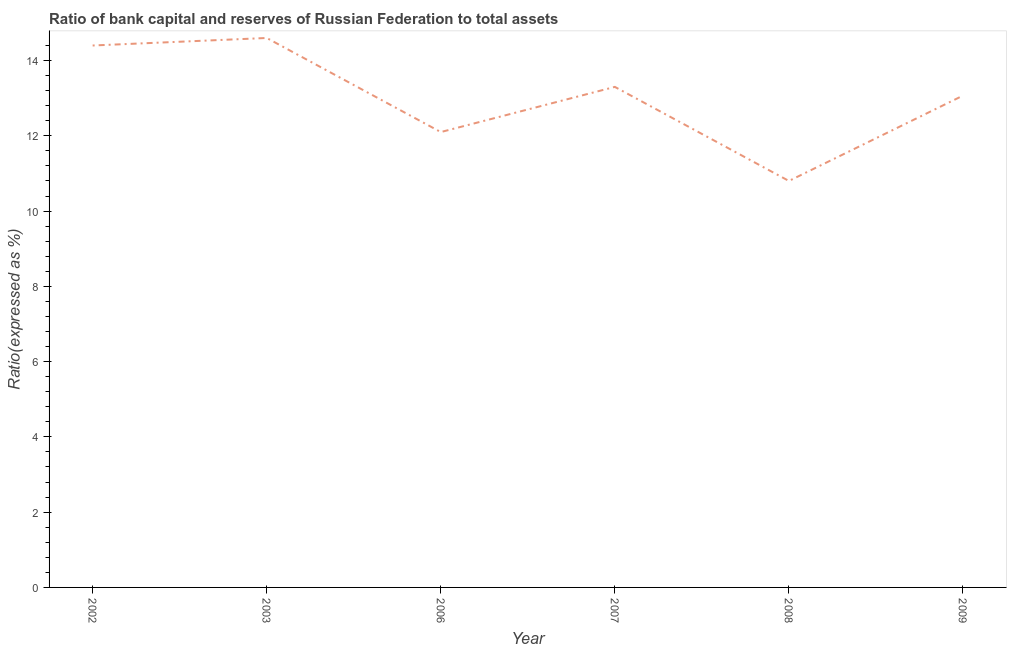Across all years, what is the minimum bank capital to assets ratio?
Make the answer very short. 10.8. In which year was the bank capital to assets ratio minimum?
Your answer should be very brief. 2008. What is the sum of the bank capital to assets ratio?
Your answer should be compact. 78.27. What is the difference between the bank capital to assets ratio in 2002 and 2009?
Give a very brief answer. 1.33. What is the average bank capital to assets ratio per year?
Provide a succinct answer. 13.04. What is the median bank capital to assets ratio?
Make the answer very short. 13.18. In how many years, is the bank capital to assets ratio greater than 9.2 %?
Offer a terse response. 6. Do a majority of the years between 2006 and 2003 (inclusive) have bank capital to assets ratio greater than 9.6 %?
Give a very brief answer. No. What is the ratio of the bank capital to assets ratio in 2002 to that in 2006?
Ensure brevity in your answer.  1.19. What is the difference between the highest and the second highest bank capital to assets ratio?
Give a very brief answer. 0.2. What is the difference between the highest and the lowest bank capital to assets ratio?
Provide a short and direct response. 3.8. Does the bank capital to assets ratio monotonically increase over the years?
Ensure brevity in your answer.  No. How many lines are there?
Your answer should be compact. 1. What is the difference between two consecutive major ticks on the Y-axis?
Keep it short and to the point. 2. Are the values on the major ticks of Y-axis written in scientific E-notation?
Ensure brevity in your answer.  No. What is the title of the graph?
Your answer should be compact. Ratio of bank capital and reserves of Russian Federation to total assets. What is the label or title of the X-axis?
Make the answer very short. Year. What is the label or title of the Y-axis?
Give a very brief answer. Ratio(expressed as %). What is the Ratio(expressed as %) in 2002?
Your response must be concise. 14.4. What is the Ratio(expressed as %) of 2003?
Your answer should be compact. 14.6. What is the Ratio(expressed as %) in 2006?
Give a very brief answer. 12.1. What is the Ratio(expressed as %) of 2008?
Ensure brevity in your answer.  10.8. What is the Ratio(expressed as %) in 2009?
Make the answer very short. 13.07. What is the difference between the Ratio(expressed as %) in 2002 and 2003?
Provide a succinct answer. -0.2. What is the difference between the Ratio(expressed as %) in 2002 and 2006?
Provide a short and direct response. 2.3. What is the difference between the Ratio(expressed as %) in 2002 and 2007?
Keep it short and to the point. 1.1. What is the difference between the Ratio(expressed as %) in 2002 and 2008?
Your response must be concise. 3.6. What is the difference between the Ratio(expressed as %) in 2002 and 2009?
Offer a very short reply. 1.33. What is the difference between the Ratio(expressed as %) in 2003 and 2006?
Offer a very short reply. 2.5. What is the difference between the Ratio(expressed as %) in 2003 and 2008?
Your answer should be very brief. 3.8. What is the difference between the Ratio(expressed as %) in 2003 and 2009?
Provide a succinct answer. 1.53. What is the difference between the Ratio(expressed as %) in 2006 and 2007?
Your response must be concise. -1.2. What is the difference between the Ratio(expressed as %) in 2006 and 2008?
Your answer should be compact. 1.3. What is the difference between the Ratio(expressed as %) in 2006 and 2009?
Give a very brief answer. -0.97. What is the difference between the Ratio(expressed as %) in 2007 and 2008?
Make the answer very short. 2.5. What is the difference between the Ratio(expressed as %) in 2007 and 2009?
Make the answer very short. 0.23. What is the difference between the Ratio(expressed as %) in 2008 and 2009?
Make the answer very short. -2.27. What is the ratio of the Ratio(expressed as %) in 2002 to that in 2006?
Offer a terse response. 1.19. What is the ratio of the Ratio(expressed as %) in 2002 to that in 2007?
Offer a terse response. 1.08. What is the ratio of the Ratio(expressed as %) in 2002 to that in 2008?
Ensure brevity in your answer.  1.33. What is the ratio of the Ratio(expressed as %) in 2002 to that in 2009?
Your answer should be very brief. 1.1. What is the ratio of the Ratio(expressed as %) in 2003 to that in 2006?
Give a very brief answer. 1.21. What is the ratio of the Ratio(expressed as %) in 2003 to that in 2007?
Provide a succinct answer. 1.1. What is the ratio of the Ratio(expressed as %) in 2003 to that in 2008?
Offer a terse response. 1.35. What is the ratio of the Ratio(expressed as %) in 2003 to that in 2009?
Your answer should be compact. 1.12. What is the ratio of the Ratio(expressed as %) in 2006 to that in 2007?
Your answer should be compact. 0.91. What is the ratio of the Ratio(expressed as %) in 2006 to that in 2008?
Offer a terse response. 1.12. What is the ratio of the Ratio(expressed as %) in 2006 to that in 2009?
Provide a short and direct response. 0.93. What is the ratio of the Ratio(expressed as %) in 2007 to that in 2008?
Provide a short and direct response. 1.23. What is the ratio of the Ratio(expressed as %) in 2007 to that in 2009?
Ensure brevity in your answer.  1.02. What is the ratio of the Ratio(expressed as %) in 2008 to that in 2009?
Provide a short and direct response. 0.83. 